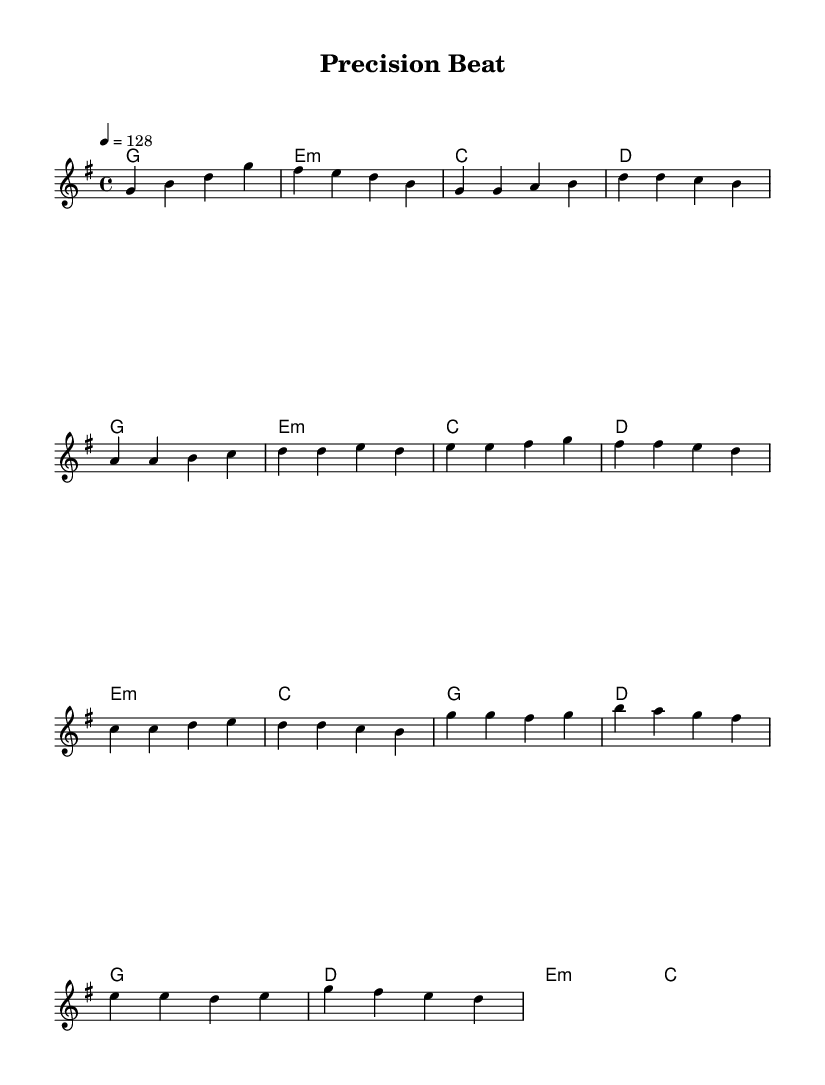What is the key signature of this music? The key signature shown at the beginning of the sheet music is G major, which has one sharp (F#).
Answer: G major What is the time signature of this piece? The time signature indicated in the music is 4/4, which means there are four beats per measure and the quarter note gets one beat.
Answer: 4/4 What is the tempo marking given at the start? The tempo marking indicates a speed of 128 beats per minute, showing how fast the piece should be played.
Answer: 128 How many bars are in the Chorus section? By counting the measures in the Chorus, there are four bars (measures) total.
Answer: 4 What is the main theme of the lyrics? The lyrics focus on problem-solving and giving attention to detail in order to achieve precision in their work.
Answer: Problem-solving and attention to detail What is the first note in the Verse? The first note in the Verse section is G, as indicated at the beginning of that section.
Answer: G What type of instruments are commonly included in energetic K-Pop tracks like this one? Energetic K-Pop tracks typically feature synthesizers, percussion, bass, and often include vocal harmonies, enhancing the overall sound.
Answer: Synthesizers, percussion, bass, vocals 